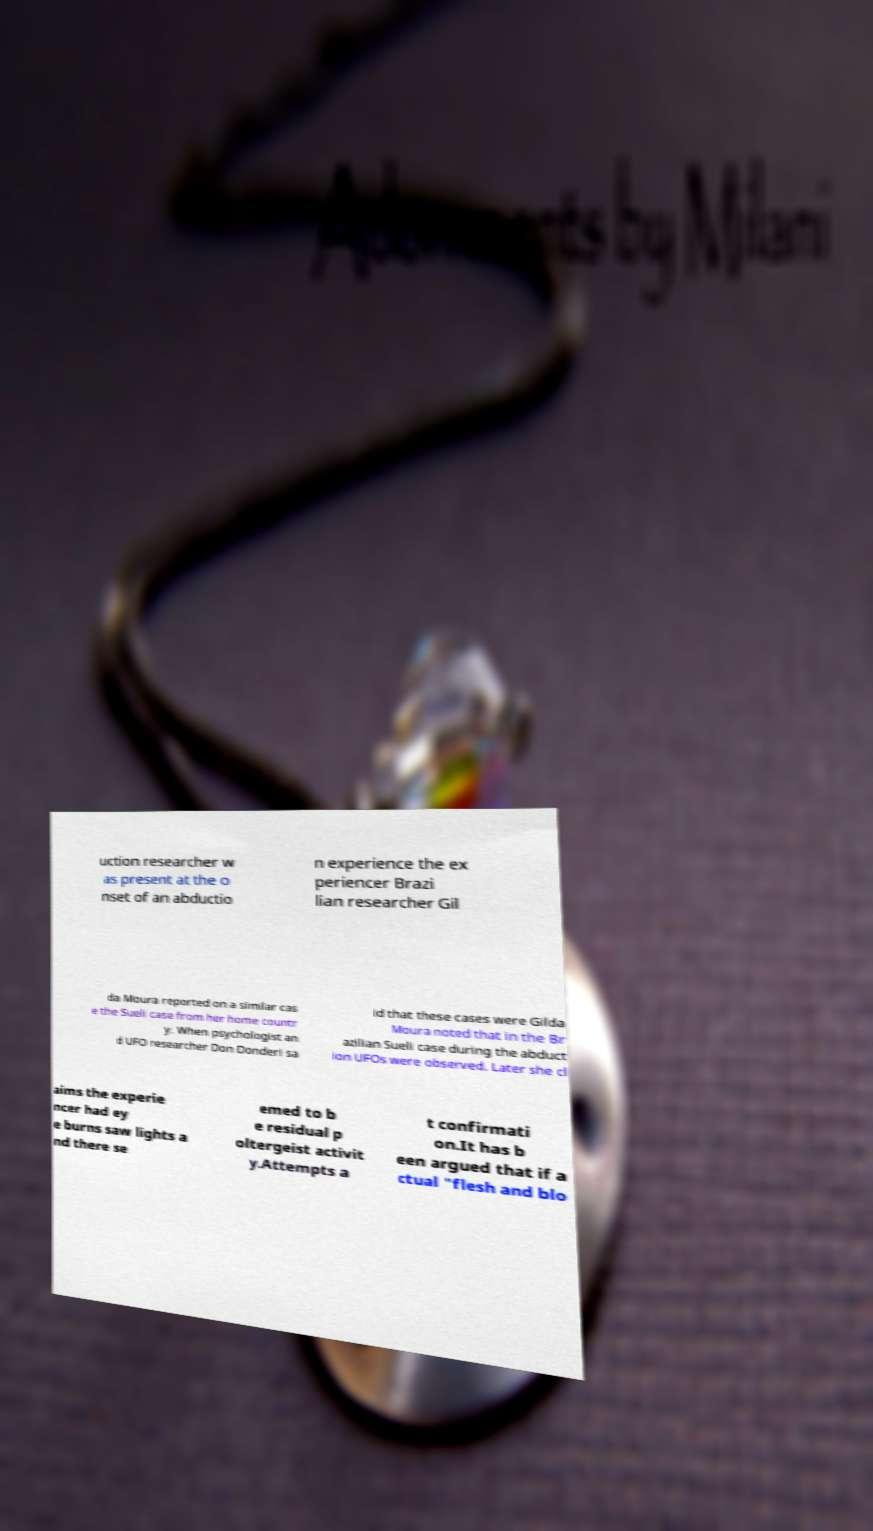Can you accurately transcribe the text from the provided image for me? uction researcher w as present at the o nset of an abductio n experience the ex periencer Brazi lian researcher Gil da Moura reported on a similar cas e the Sueli case from her home countr y. When psychologist an d UFO researcher Don Donderi sa id that these cases were Gilda Moura noted that in the Br azilian Sueli case during the abduct ion UFOs were observed. Later she cl aims the experie ncer had ey e burns saw lights a nd there se emed to b e residual p oltergeist activit y.Attempts a t confirmati on.It has b een argued that if a ctual "flesh and blo 